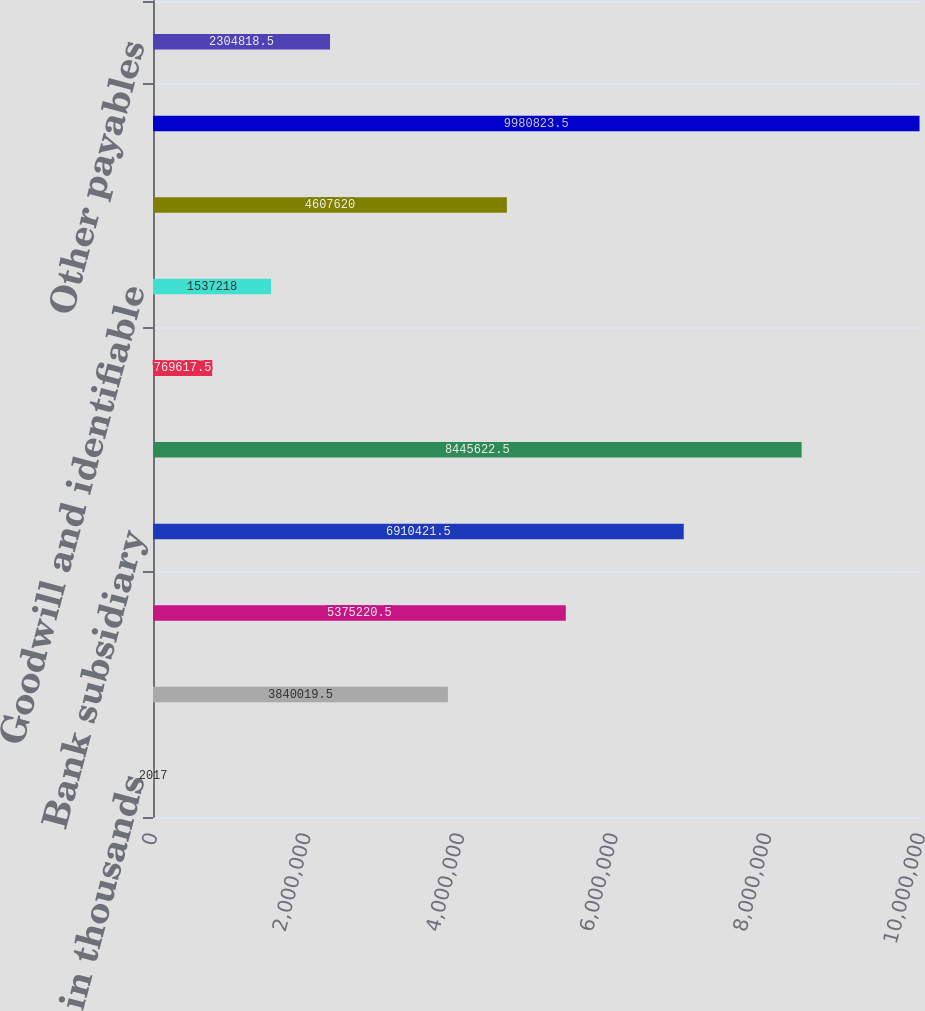Convert chart. <chart><loc_0><loc_0><loc_500><loc_500><bar_chart><fcel>in thousands<fcel>Cash and cash equivalents<fcel>Non-bank subsidiaries (1)<fcel>Bank subsidiary<fcel>Non-bank subsidiaries<fcel>Property and equipment net<fcel>Goodwill and identifiable<fcel>Other assets<fcel>Total assets<fcel>Other payables<nl><fcel>2017<fcel>3.84002e+06<fcel>5.37522e+06<fcel>6.91042e+06<fcel>8.44562e+06<fcel>769618<fcel>1.53722e+06<fcel>4.60762e+06<fcel>9.98082e+06<fcel>2.30482e+06<nl></chart> 